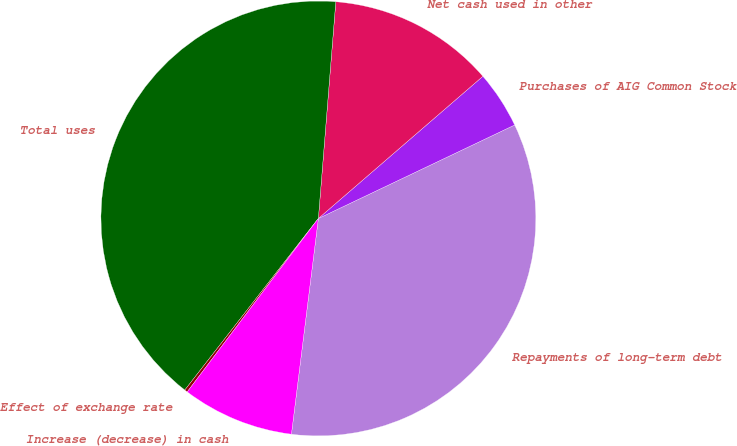Convert chart. <chart><loc_0><loc_0><loc_500><loc_500><pie_chart><fcel>Repayments of long-term debt<fcel>Purchases of AIG Common Stock<fcel>Net cash used in other<fcel>Total uses<fcel>Effect of exchange rate<fcel>Increase (decrease) in cash<nl><fcel>34.05%<fcel>4.27%<fcel>12.38%<fcel>40.75%<fcel>0.22%<fcel>8.33%<nl></chart> 